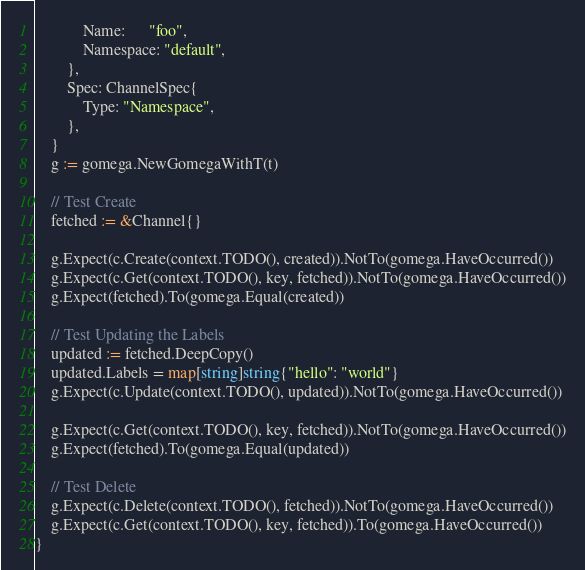Convert code to text. <code><loc_0><loc_0><loc_500><loc_500><_Go_>			Name:      "foo",
			Namespace: "default",
		},
		Spec: ChannelSpec{
			Type: "Namespace",
		},
	}
	g := gomega.NewGomegaWithT(t)

	// Test Create
	fetched := &Channel{}

	g.Expect(c.Create(context.TODO(), created)).NotTo(gomega.HaveOccurred())
	g.Expect(c.Get(context.TODO(), key, fetched)).NotTo(gomega.HaveOccurred())
	g.Expect(fetched).To(gomega.Equal(created))

	// Test Updating the Labels
	updated := fetched.DeepCopy()
	updated.Labels = map[string]string{"hello": "world"}
	g.Expect(c.Update(context.TODO(), updated)).NotTo(gomega.HaveOccurred())

	g.Expect(c.Get(context.TODO(), key, fetched)).NotTo(gomega.HaveOccurred())
	g.Expect(fetched).To(gomega.Equal(updated))

	// Test Delete
	g.Expect(c.Delete(context.TODO(), fetched)).NotTo(gomega.HaveOccurred())
	g.Expect(c.Get(context.TODO(), key, fetched)).To(gomega.HaveOccurred())
}
</code> 